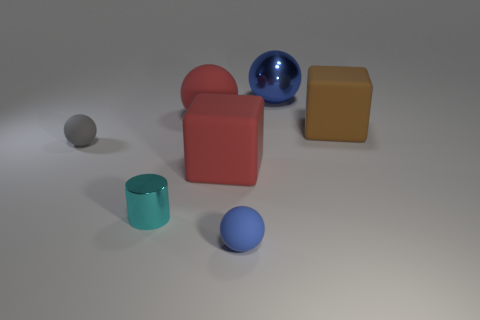What color is the rubber cube in front of the matte block on the right side of the block in front of the gray sphere?
Your answer should be very brief. Red. Do the metal cylinder and the gray rubber ball have the same size?
Give a very brief answer. Yes. Is there anything else that is the same shape as the cyan metallic object?
Make the answer very short. No. How many objects are red rubber objects that are in front of the brown object or large brown cubes?
Make the answer very short. 2. Do the tiny blue thing and the brown thing have the same shape?
Provide a short and direct response. No. What number of other objects are there of the same size as the metallic ball?
Offer a very short reply. 3. The tiny shiny cylinder is what color?
Offer a very short reply. Cyan. How many large things are gray objects or blue shiny things?
Your answer should be very brief. 1. Does the metal thing that is behind the small shiny cylinder have the same size as the shiny thing that is left of the small blue object?
Your response must be concise. No. What is the size of the blue matte thing that is the same shape as the large metallic object?
Offer a very short reply. Small. 